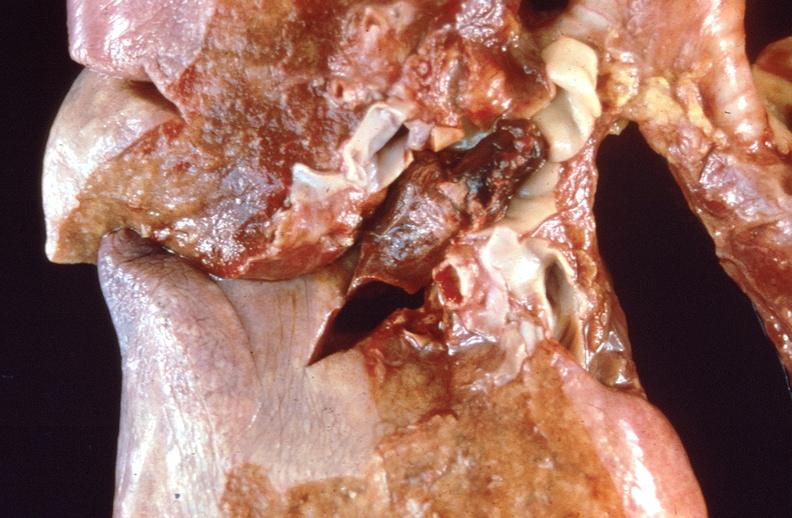does this image show pulmonary thromboemboli?
Answer the question using a single word or phrase. Yes 